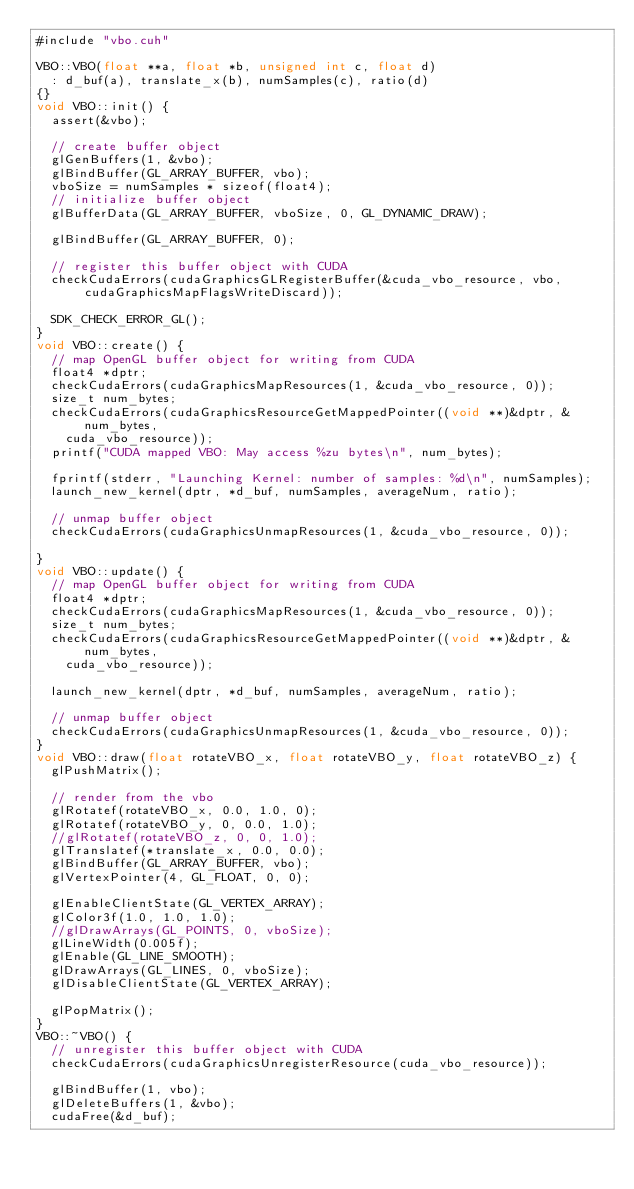Convert code to text. <code><loc_0><loc_0><loc_500><loc_500><_Cuda_>#include "vbo.cuh"

VBO::VBO(float **a, float *b, unsigned int c, float d)
	: d_buf(a), translate_x(b), numSamples(c), ratio(d)
{}
void VBO::init() {
	assert(&vbo);

	// create buffer object
	glGenBuffers(1, &vbo);
	glBindBuffer(GL_ARRAY_BUFFER, vbo);
	vboSize = numSamples * sizeof(float4);
	// initialize buffer object
	glBufferData(GL_ARRAY_BUFFER, vboSize, 0, GL_DYNAMIC_DRAW);

	glBindBuffer(GL_ARRAY_BUFFER, 0);

	// register this buffer object with CUDA
	checkCudaErrors(cudaGraphicsGLRegisterBuffer(&cuda_vbo_resource, vbo, cudaGraphicsMapFlagsWriteDiscard));

	SDK_CHECK_ERROR_GL();
}
void VBO::create() {
	// map OpenGL buffer object for writing from CUDA
	float4 *dptr;
	checkCudaErrors(cudaGraphicsMapResources(1, &cuda_vbo_resource, 0));
	size_t num_bytes;
	checkCudaErrors(cudaGraphicsResourceGetMappedPointer((void **)&dptr, &num_bytes,
		cuda_vbo_resource));
	printf("CUDA mapped VBO: May access %zu bytes\n", num_bytes);

	fprintf(stderr, "Launching Kernel: number of samples: %d\n", numSamples);
	launch_new_kernel(dptr, *d_buf, numSamples, averageNum, ratio);

	// unmap buffer object
	checkCudaErrors(cudaGraphicsUnmapResources(1, &cuda_vbo_resource, 0));

}
void VBO::update() {
	// map OpenGL buffer object for writing from CUDA
	float4 *dptr;
	checkCudaErrors(cudaGraphicsMapResources(1, &cuda_vbo_resource, 0));
	size_t num_bytes;
	checkCudaErrors(cudaGraphicsResourceGetMappedPointer((void **)&dptr, &num_bytes,
		cuda_vbo_resource));

	launch_new_kernel(dptr, *d_buf, numSamples, averageNum, ratio);

	// unmap buffer object
	checkCudaErrors(cudaGraphicsUnmapResources(1, &cuda_vbo_resource, 0));
}
void VBO::draw(float rotateVBO_x, float rotateVBO_y, float rotateVBO_z) {
	glPushMatrix();

	// render from the vbo
	glRotatef(rotateVBO_x, 0.0, 1.0, 0);
	glRotatef(rotateVBO_y, 0, 0.0, 1.0);
	//glRotatef(rotateVBO_z, 0, 0, 1.0);
	glTranslatef(*translate_x, 0.0, 0.0);
	glBindBuffer(GL_ARRAY_BUFFER, vbo);
	glVertexPointer(4, GL_FLOAT, 0, 0);

	glEnableClientState(GL_VERTEX_ARRAY);
	glColor3f(1.0, 1.0, 1.0);
	//glDrawArrays(GL_POINTS, 0, vboSize);
	glLineWidth(0.005f);
	glEnable(GL_LINE_SMOOTH);
	glDrawArrays(GL_LINES, 0, vboSize);
	glDisableClientState(GL_VERTEX_ARRAY);

	glPopMatrix();
}
VBO::~VBO() {
	// unregister this buffer object with CUDA
	checkCudaErrors(cudaGraphicsUnregisterResource(cuda_vbo_resource));

	glBindBuffer(1, vbo);
	glDeleteBuffers(1, &vbo);
	cudaFree(&d_buf);</code> 